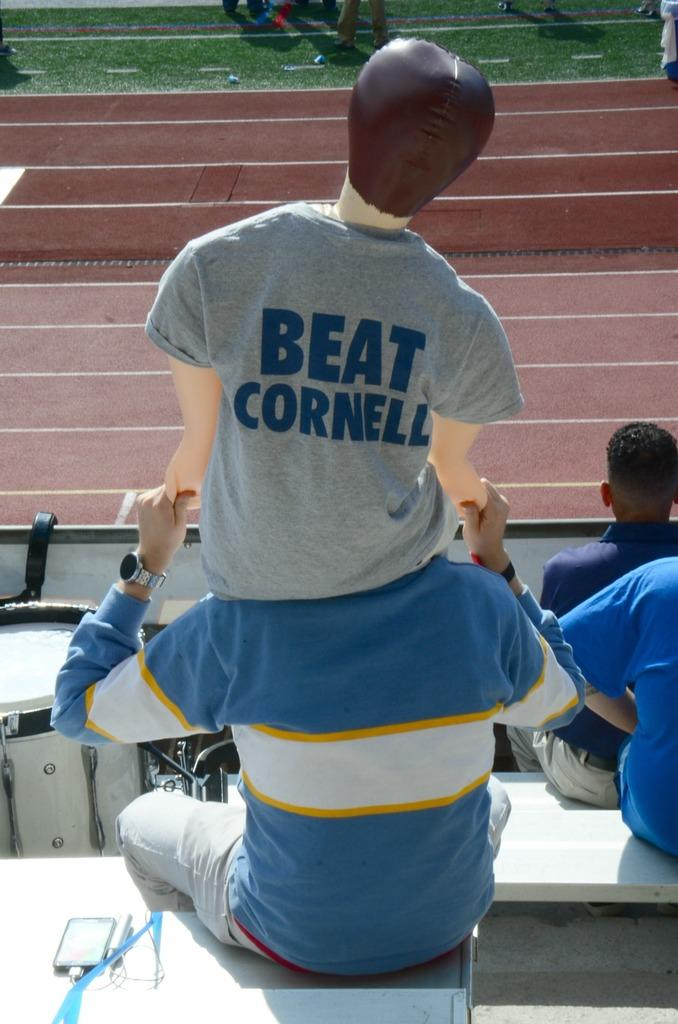Provide a one-sentence caption for the provided image. A man sitting in the bleachers watching some type of event holding a blow up doll on his shoulders that is wearing a shirt that says BEAT CORNELL. 